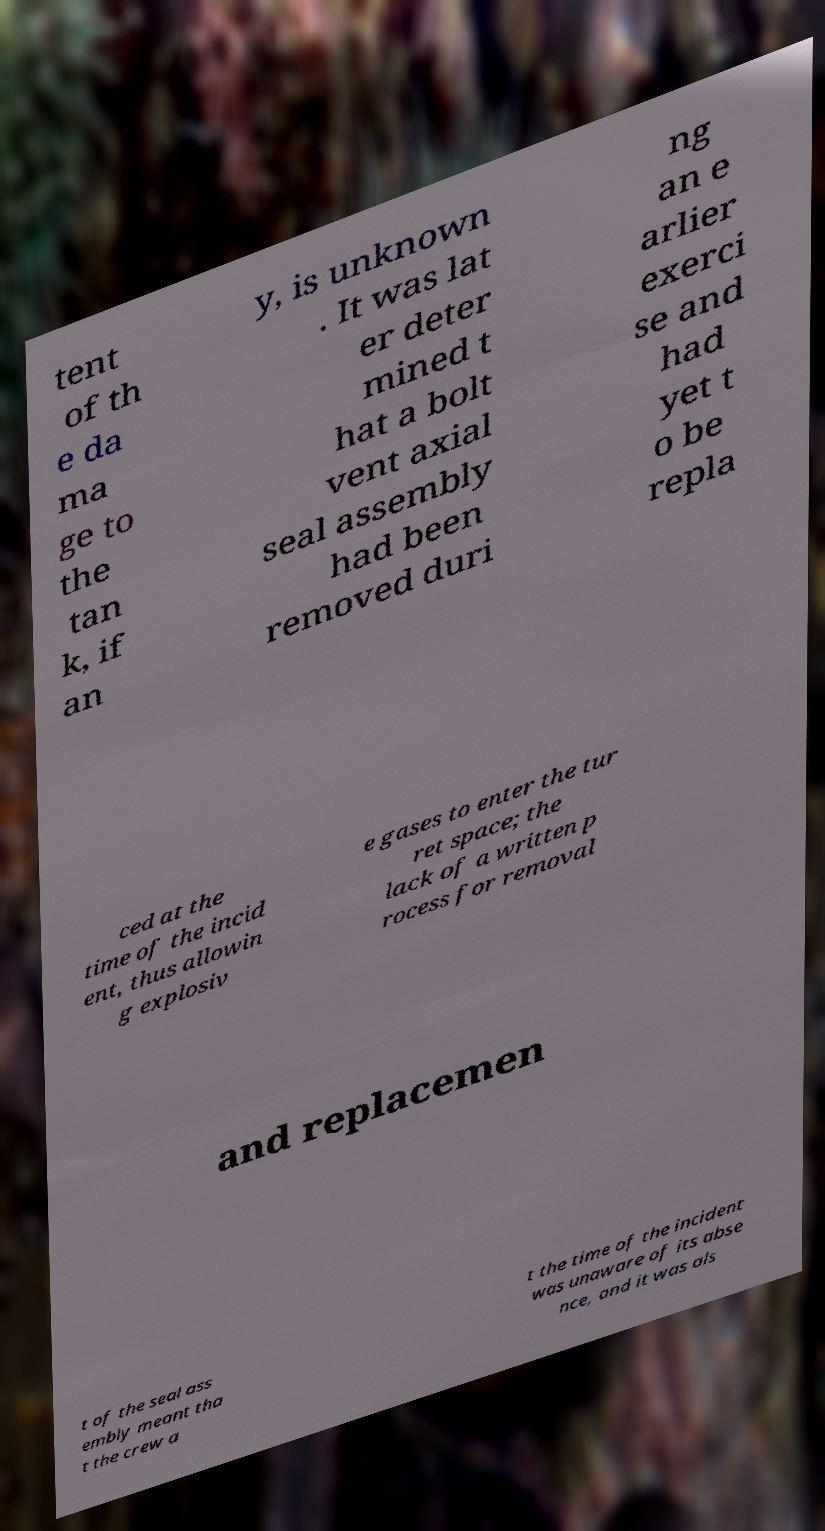What messages or text are displayed in this image? I need them in a readable, typed format. tent of th e da ma ge to the tan k, if an y, is unknown . It was lat er deter mined t hat a bolt vent axial seal assembly had been removed duri ng an e arlier exerci se and had yet t o be repla ced at the time of the incid ent, thus allowin g explosiv e gases to enter the tur ret space; the lack of a written p rocess for removal and replacemen t of the seal ass embly meant tha t the crew a t the time of the incident was unaware of its abse nce, and it was als 